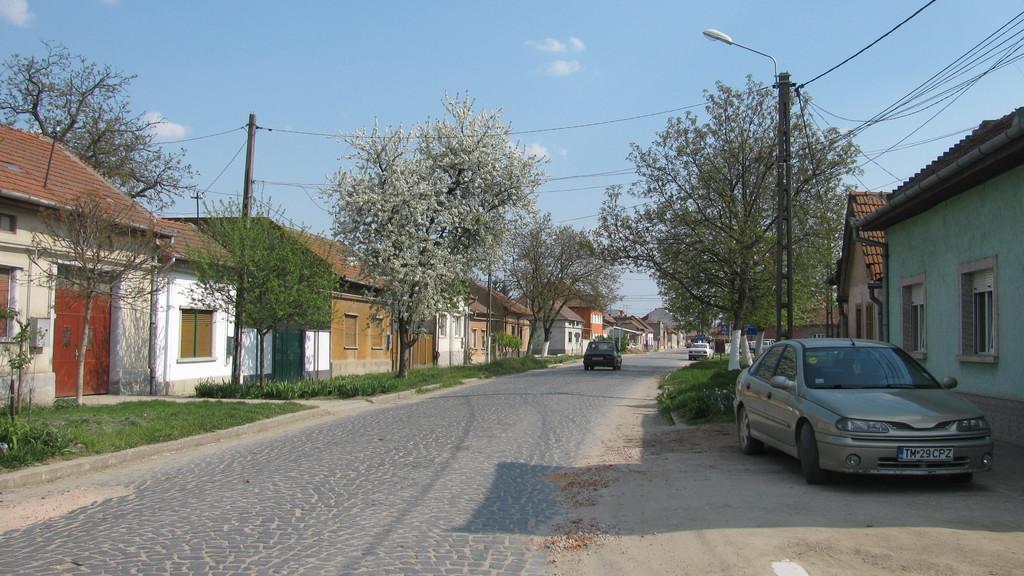In one or two sentences, can you explain what this image depicts? In this picture we can see there are some vehicles on the path. On the left and right side of the vehicles there are trees, houses, electric poles with cables and light. Behind the trees there is a sky. 